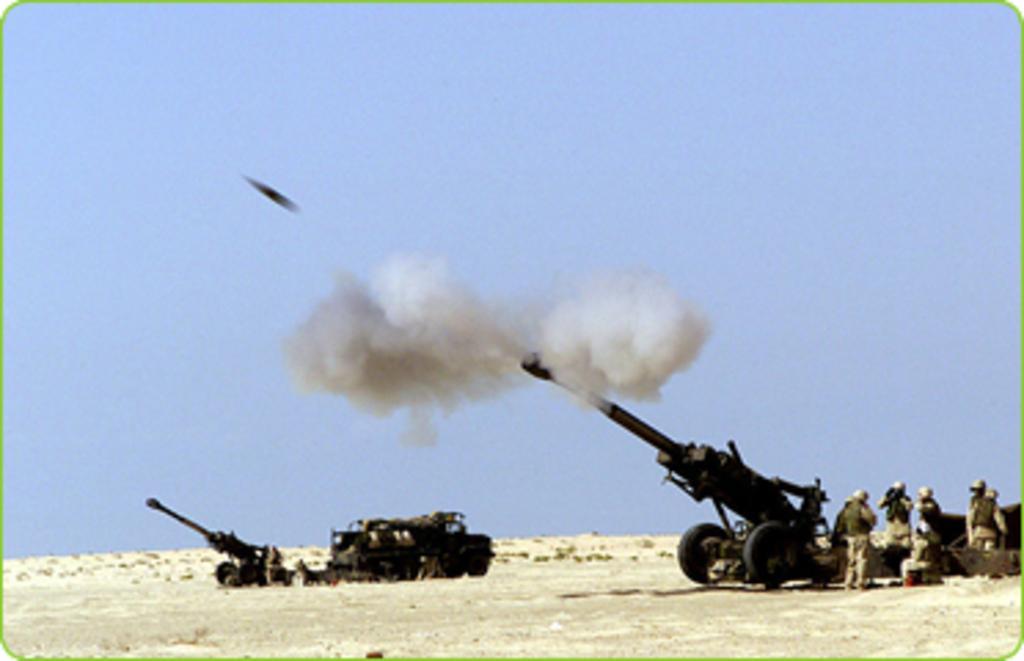Could you give a brief overview of what you see in this image? In this image I can see a group of people are standing on the ground and missile tankers. In the background I can see the sky and smoke. This image is taken during a day on the ground. 